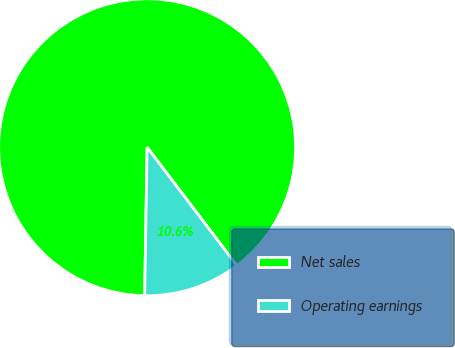<chart> <loc_0><loc_0><loc_500><loc_500><pie_chart><fcel>Net sales<fcel>Operating earnings<nl><fcel>89.41%<fcel>10.59%<nl></chart> 